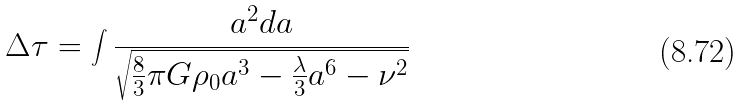Convert formula to latex. <formula><loc_0><loc_0><loc_500><loc_500>\Delta \tau = \int \frac { a ^ { 2 } d a } { \sqrt { \frac { 8 } { 3 } \pi G \rho _ { 0 } a ^ { 3 } - \frac { \lambda } { 3 } a ^ { 6 } - \nu ^ { 2 } } }</formula> 